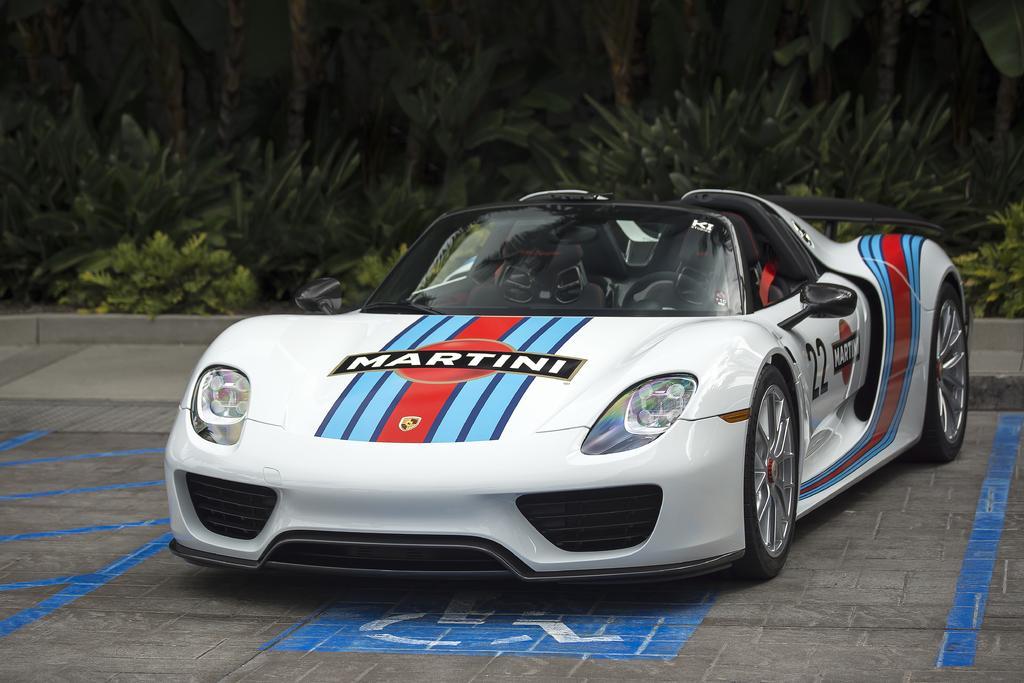Please provide a concise description of this image. In this picture we can see a car on the road. There are some plants in the background. 